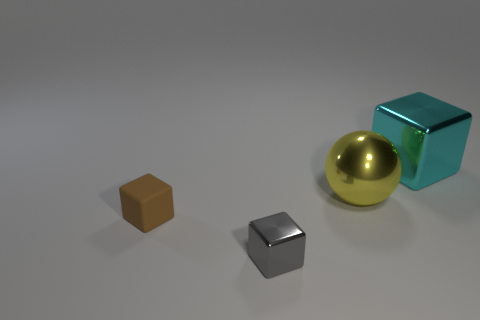Add 4 metallic blocks. How many objects exist? 8 Subtract all spheres. How many objects are left? 3 Add 1 tiny objects. How many tiny objects are left? 3 Add 1 gray blocks. How many gray blocks exist? 2 Subtract 0 blue cylinders. How many objects are left? 4 Subtract all gray cylinders. Subtract all small metal things. How many objects are left? 3 